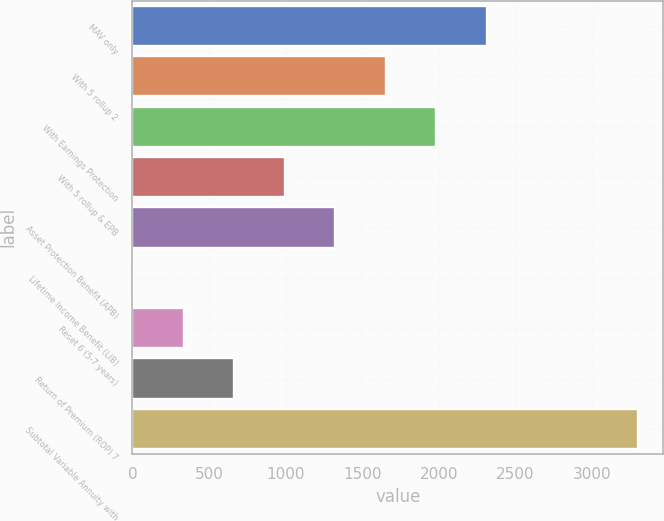Convert chart. <chart><loc_0><loc_0><loc_500><loc_500><bar_chart><fcel>MAV only<fcel>With 5 rollup 2<fcel>With Earnings Protection<fcel>With 5 rollup & EPB<fcel>Asset Protection Benefit (APB)<fcel>Lifetime Income Benefit (LIB)<fcel>Reset 6 (5-7 years)<fcel>Return of Premium (ROP) 7<fcel>Subtotal Variable Annuity with<nl><fcel>2310.4<fcel>1652<fcel>1981.2<fcel>993.6<fcel>1322.8<fcel>6<fcel>335.2<fcel>664.4<fcel>3298<nl></chart> 